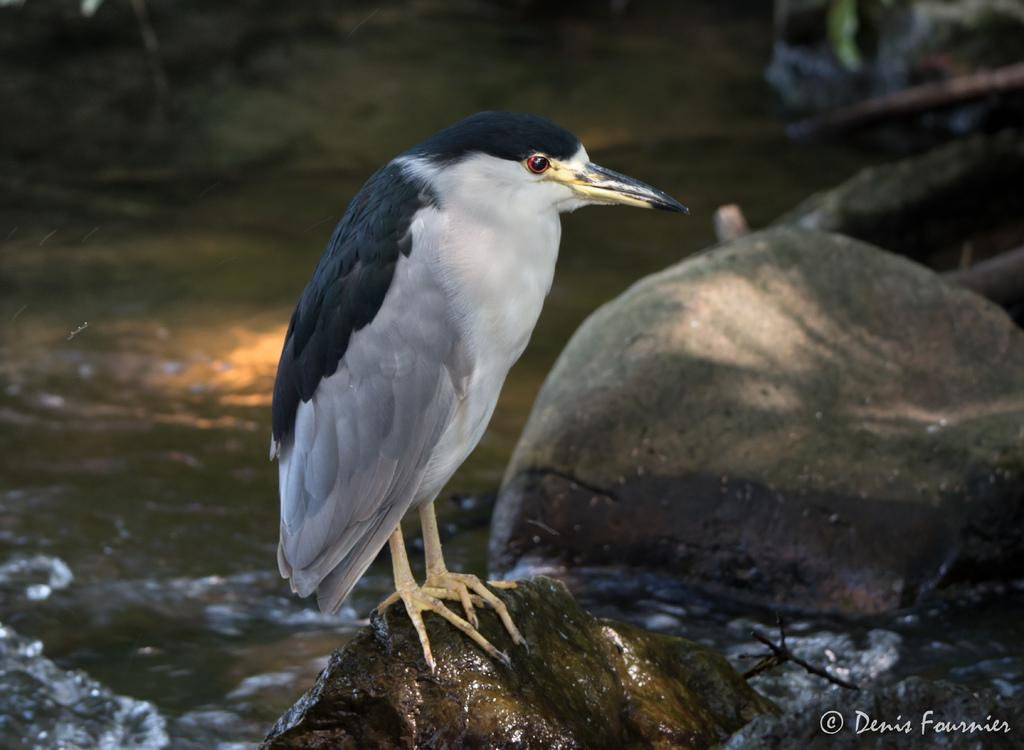What animal can be seen in the image? There is a bird on a stone in the image. What is visible at the bottom of the image? There is water visible at the bottom of the image. Where is the text located in the image? The text is on the right side of the image. What type of money is floating in the water in the image? There is no money visible in the image; it only features a bird on a stone, water at the bottom, and text on the right side. 